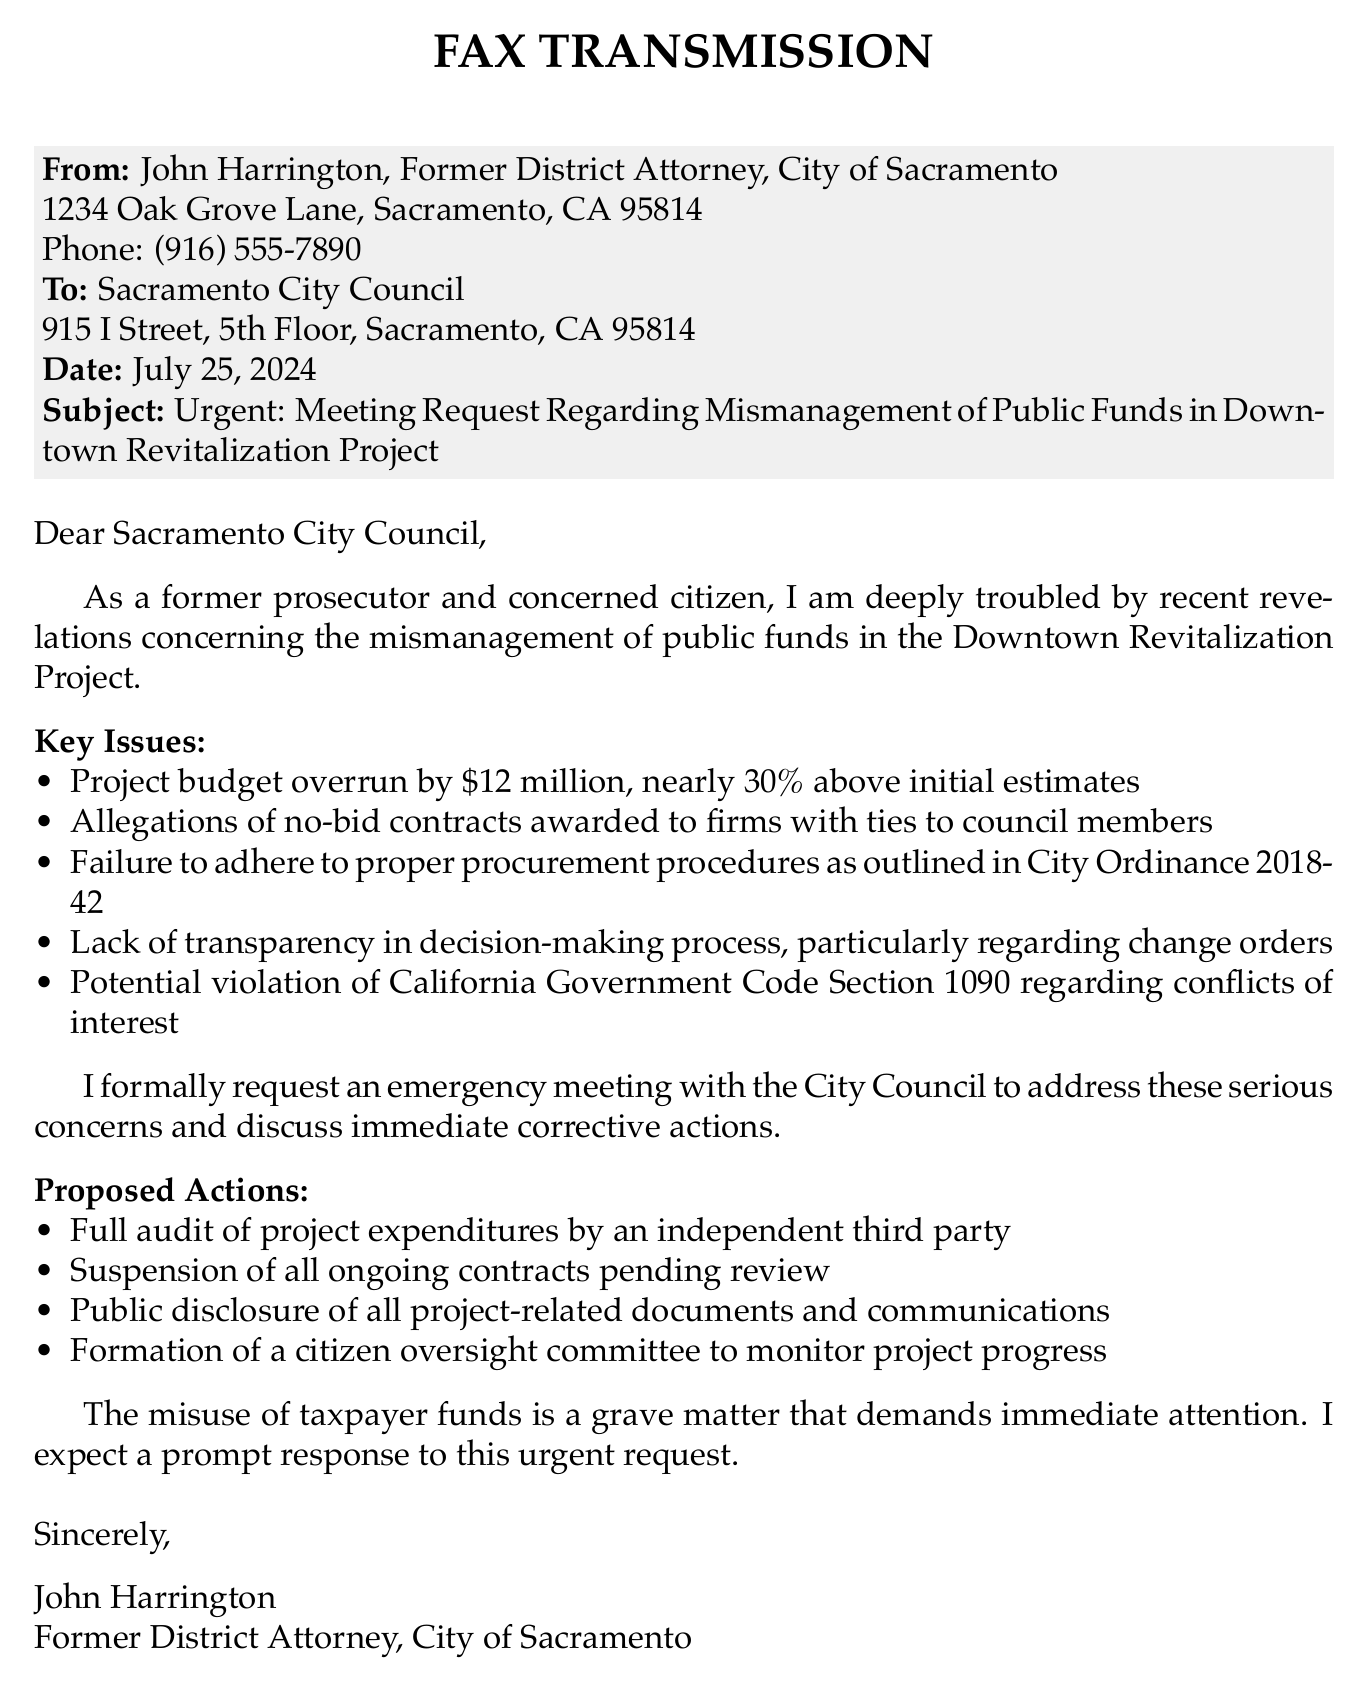What is the sender's name? The sender's name is mentioned at the beginning of the document as John Harrington.
Answer: John Harrington What is the subject of the fax? The subject line clearly states the main topic of the fax regarding the urgent meeting request.
Answer: Urgent: Meeting Request Regarding Mismanagement of Public Funds in Downtown Revitalization Project What is the budget overrun amount? The document specifies the amount by which the project budget has been exceeded.
Answer: $12 million What is the percentage of the budget overrun? The document indicates the percentage increase over the initial budget estimates.
Answer: 30% What does the sender request in terms of actions? The document outlines the proposed actions the sender wants the City Council to consider.
Answer: Full audit of project expenditures by an independent third party What is the date of the fax? The document provides the current date as the date of transmission.
Answer: Today's date How many key issues are listed? The number of key issues identified in the document is noted through the itemized list.
Answer: Five What is the purpose of the requested emergency meeting? The document indicates that the meeting is aimed at addressing serious concerns over specific issues.
Answer: Address serious concerns What ordinance is mentioned in relation to procurement procedures? The document cites a specific city ordinance relevant to the procurement process for the project.
Answer: City Ordinance 2018-42 Who is the recipient of the fax? The fax specifies the intended recipient organization.
Answer: Sacramento City Council 